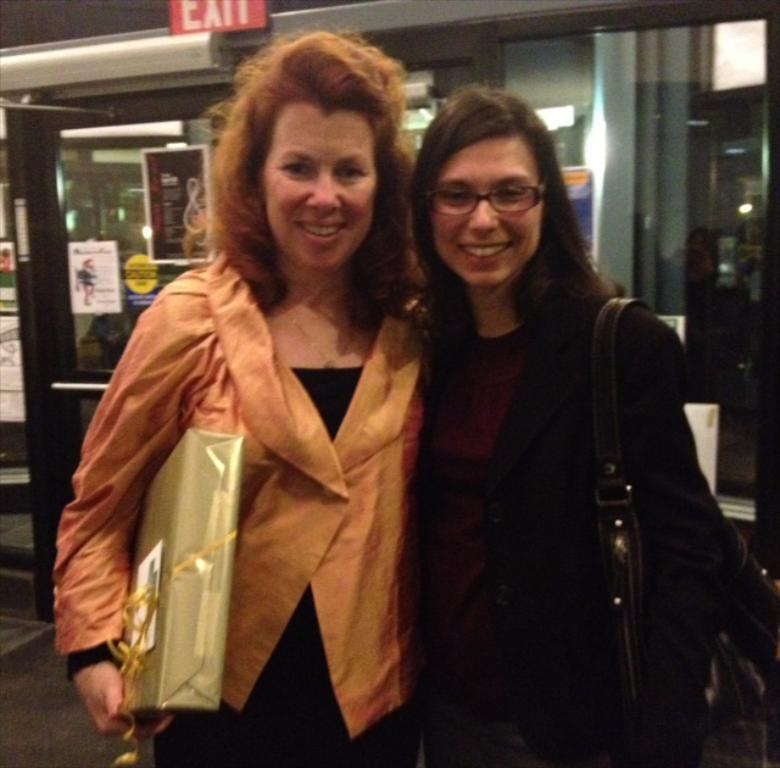How many women are in the image? There are two women in the image. What are the women doing in the image? The women are standing and smiling. What can be seen in the background of the image? There is a shop in the background of the image. What is the color of the EXIT sign board at the top of the image? The EXIT sign board is red. What type of silk is being used to make the kite in the image? There is no kite present in the image, so silk is not being used for any purpose. 